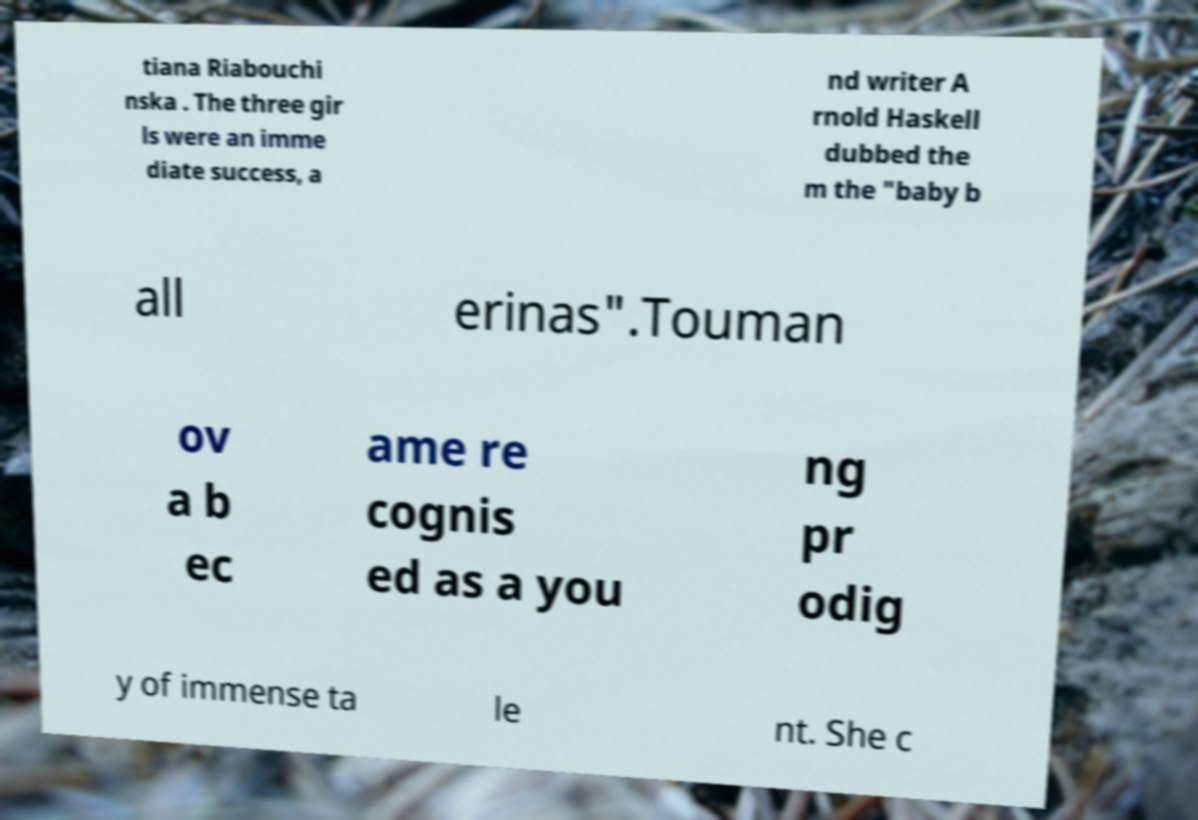There's text embedded in this image that I need extracted. Can you transcribe it verbatim? tiana Riabouchi nska . The three gir ls were an imme diate success, a nd writer A rnold Haskell dubbed the m the "baby b all erinas".Touman ov a b ec ame re cognis ed as a you ng pr odig y of immense ta le nt. She c 